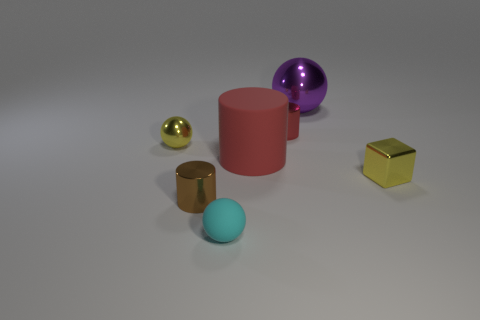Subtract all yellow shiny spheres. How many spheres are left? 2 Subtract all yellow cubes. How many red cylinders are left? 2 Add 2 red rubber cylinders. How many objects exist? 9 Subtract all cubes. How many objects are left? 6 Add 1 yellow objects. How many yellow objects are left? 3 Add 6 tiny cylinders. How many tiny cylinders exist? 8 Subtract 0 yellow cylinders. How many objects are left? 7 Subtract all blue balls. Subtract all purple cylinders. How many balls are left? 3 Subtract all blue matte cylinders. Subtract all big matte things. How many objects are left? 6 